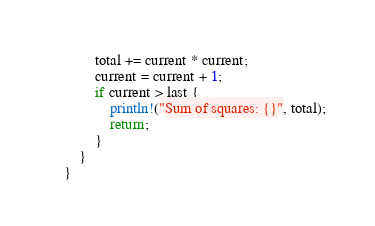Convert code to text. <code><loc_0><loc_0><loc_500><loc_500><_Rust_>        total += current * current;
        current = current + 1;
        if current > last {
            println!("Sum of squares: {}", total);
            return;
        }
    }
}
</code> 